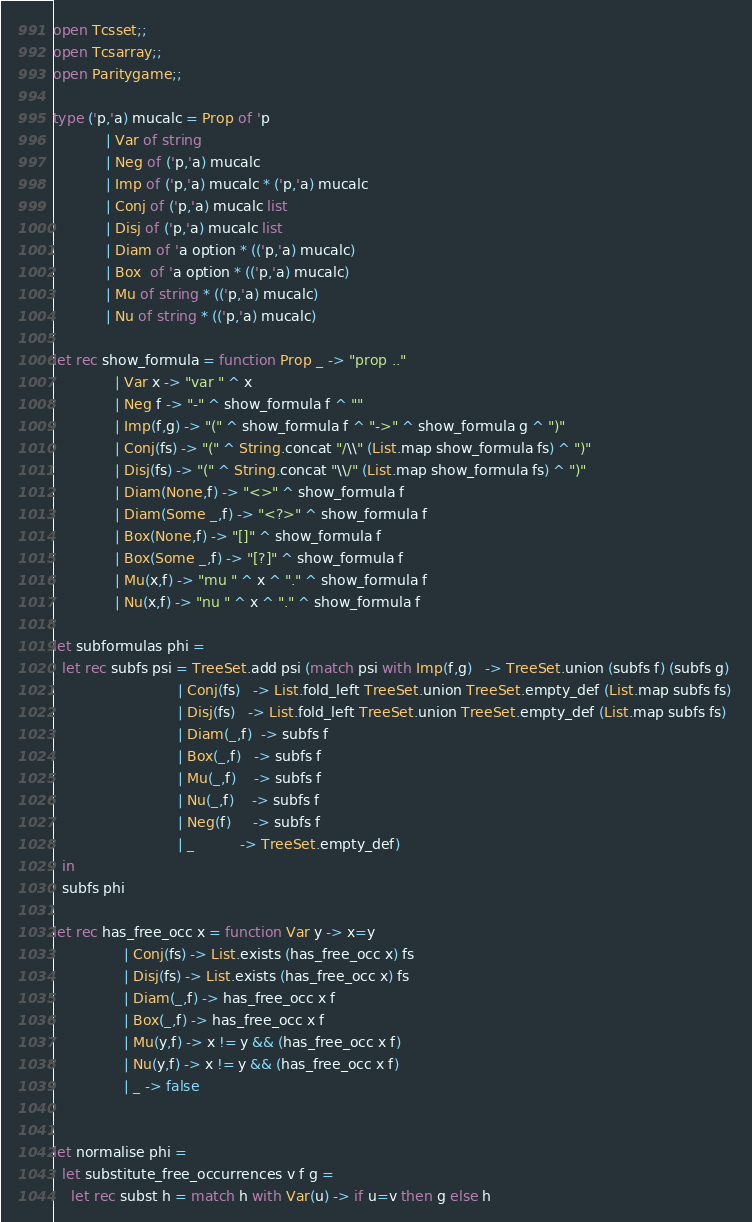Convert code to text. <code><loc_0><loc_0><loc_500><loc_500><_OCaml_>open Tcsset;;
open Tcsarray;;
open Paritygame;;
  
type ('p,'a) mucalc = Prop of 'p
		    | Var of string
		    | Neg of ('p,'a) mucalc
		    | Imp of ('p,'a) mucalc * ('p,'a) mucalc
		    | Conj of ('p,'a) mucalc list 
		    | Disj of ('p,'a) mucalc list
		    | Diam of 'a option * (('p,'a) mucalc)
		    | Box  of 'a option * (('p,'a) mucalc)
		    | Mu of string * (('p,'a) mucalc)
		    | Nu of string * (('p,'a) mucalc)

let rec show_formula = function Prop _ -> "prop .."
			  | Var x -> "var " ^ x
			  | Neg f -> "-" ^ show_formula f ^ ""
			  | Imp(f,g) -> "(" ^ show_formula f ^ "->" ^ show_formula g ^ ")"
			  | Conj(fs) -> "(" ^ String.concat "/\\" (List.map show_formula fs) ^ ")"
			  | Disj(fs) -> "(" ^ String.concat "\\/" (List.map show_formula fs) ^ ")"
			  | Diam(None,f) -> "<>" ^ show_formula f
			  | Diam(Some _,f) -> "<?>" ^ show_formula f
			  | Box(None,f) -> "[]" ^ show_formula f
			  | Box(Some _,f) -> "[?]" ^ show_formula f
			  | Mu(x,f) -> "mu " ^ x ^ "." ^ show_formula f
			  | Nu(x,f) -> "nu " ^ x ^ "." ^ show_formula f
								
let subformulas phi =
  let rec subfs psi = TreeSet.add psi (match psi with Imp(f,g)   -> TreeSet.union (subfs f) (subfs g)
						    | Conj(fs)   -> List.fold_left TreeSet.union TreeSet.empty_def (List.map subfs fs) 
						    | Disj(fs)   -> List.fold_left TreeSet.union TreeSet.empty_def (List.map subfs fs)
						    | Diam(_,f)  -> subfs f
						    | Box(_,f)   -> subfs f
						    | Mu(_,f)    -> subfs f
						    | Nu(_,f)    -> subfs f
						    | Neg(f)     -> subfs f
						    | _          -> TreeSet.empty_def) 
  in
  subfs phi

let rec has_free_occ x = function Var y -> x=y
				| Conj(fs) -> List.exists (has_free_occ x) fs
				| Disj(fs) -> List.exists (has_free_occ x) fs 
				| Diam(_,f) -> has_free_occ x f 
				| Box(_,f) -> has_free_occ x f 
				| Mu(y,f) -> x != y && (has_free_occ x f) 
				| Nu(y,f) -> x != y && (has_free_occ x f)
				| _ -> false


let normalise phi = 
  let substitute_free_occurrences v f g =
    let rec subst h = match h with Var(u) -> if u=v then g else h</code> 